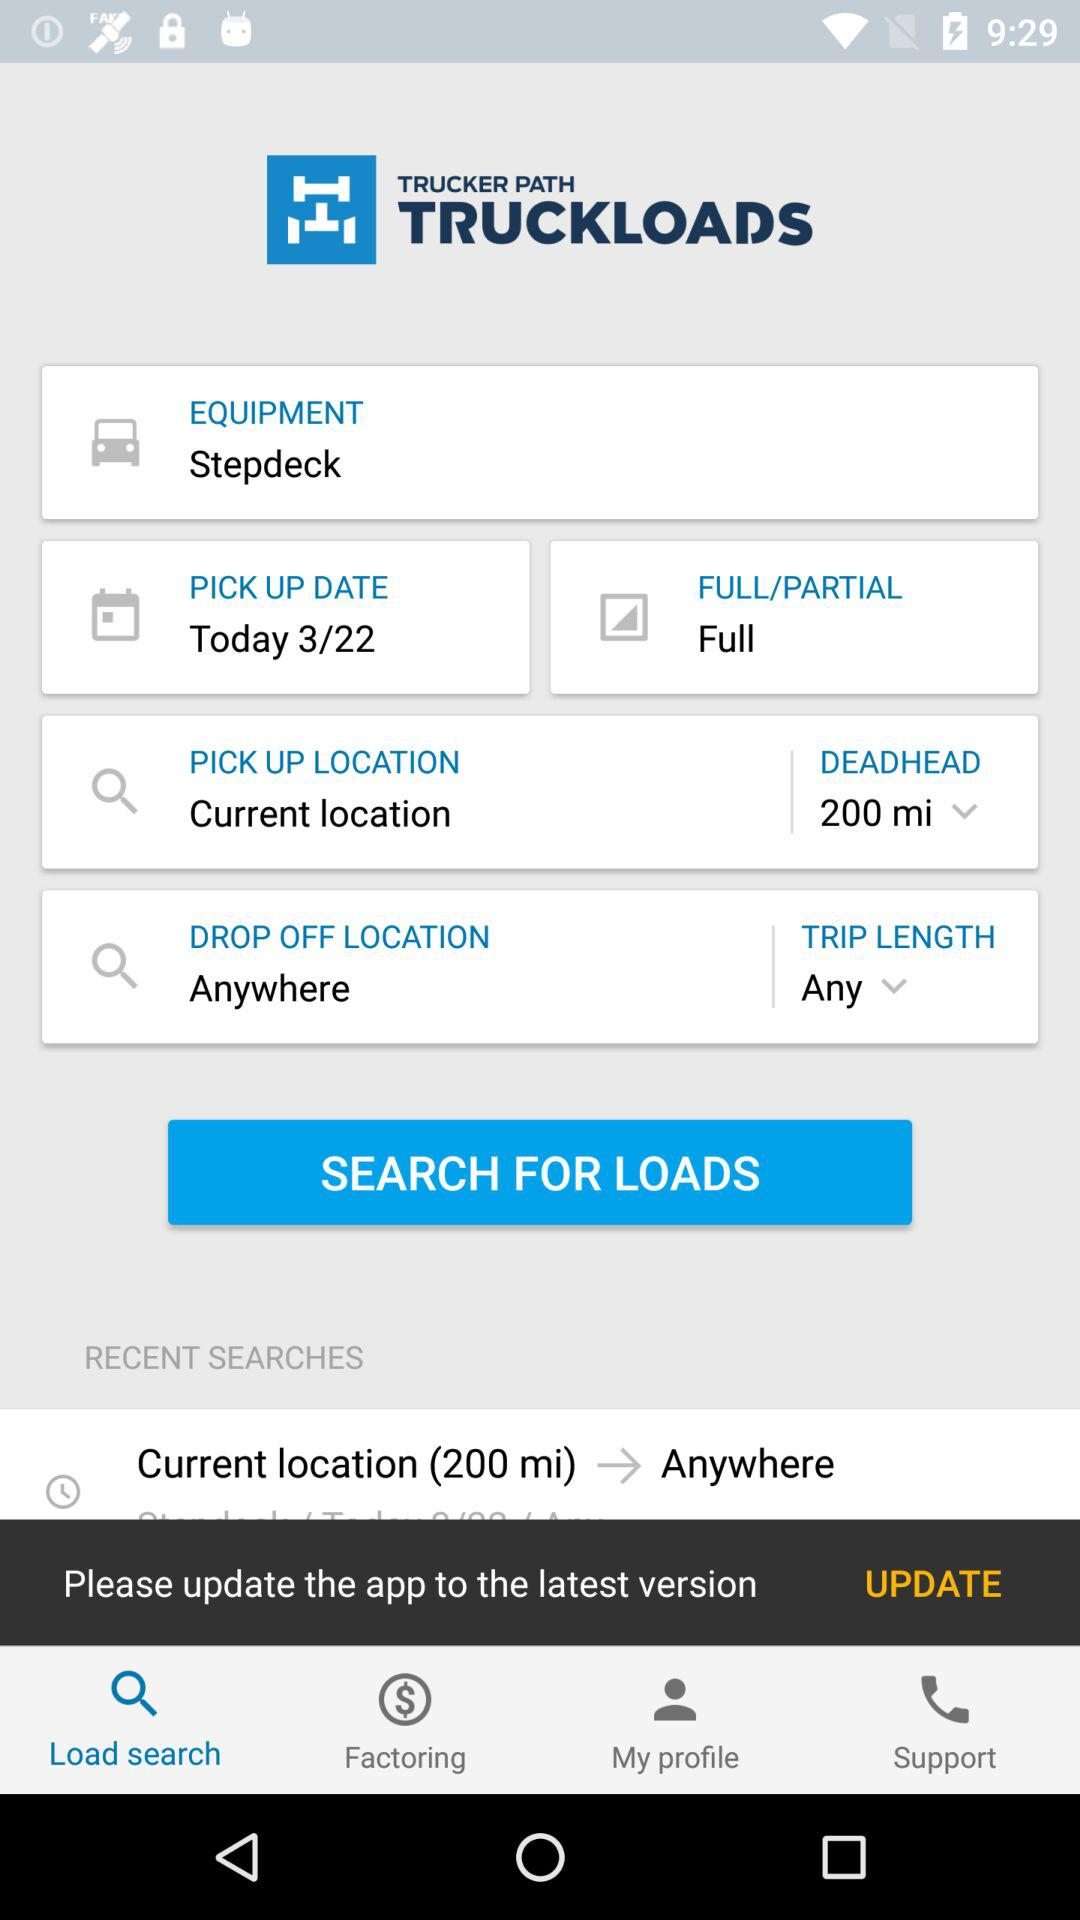Which tab is selected? The selected tab is "Load search". 